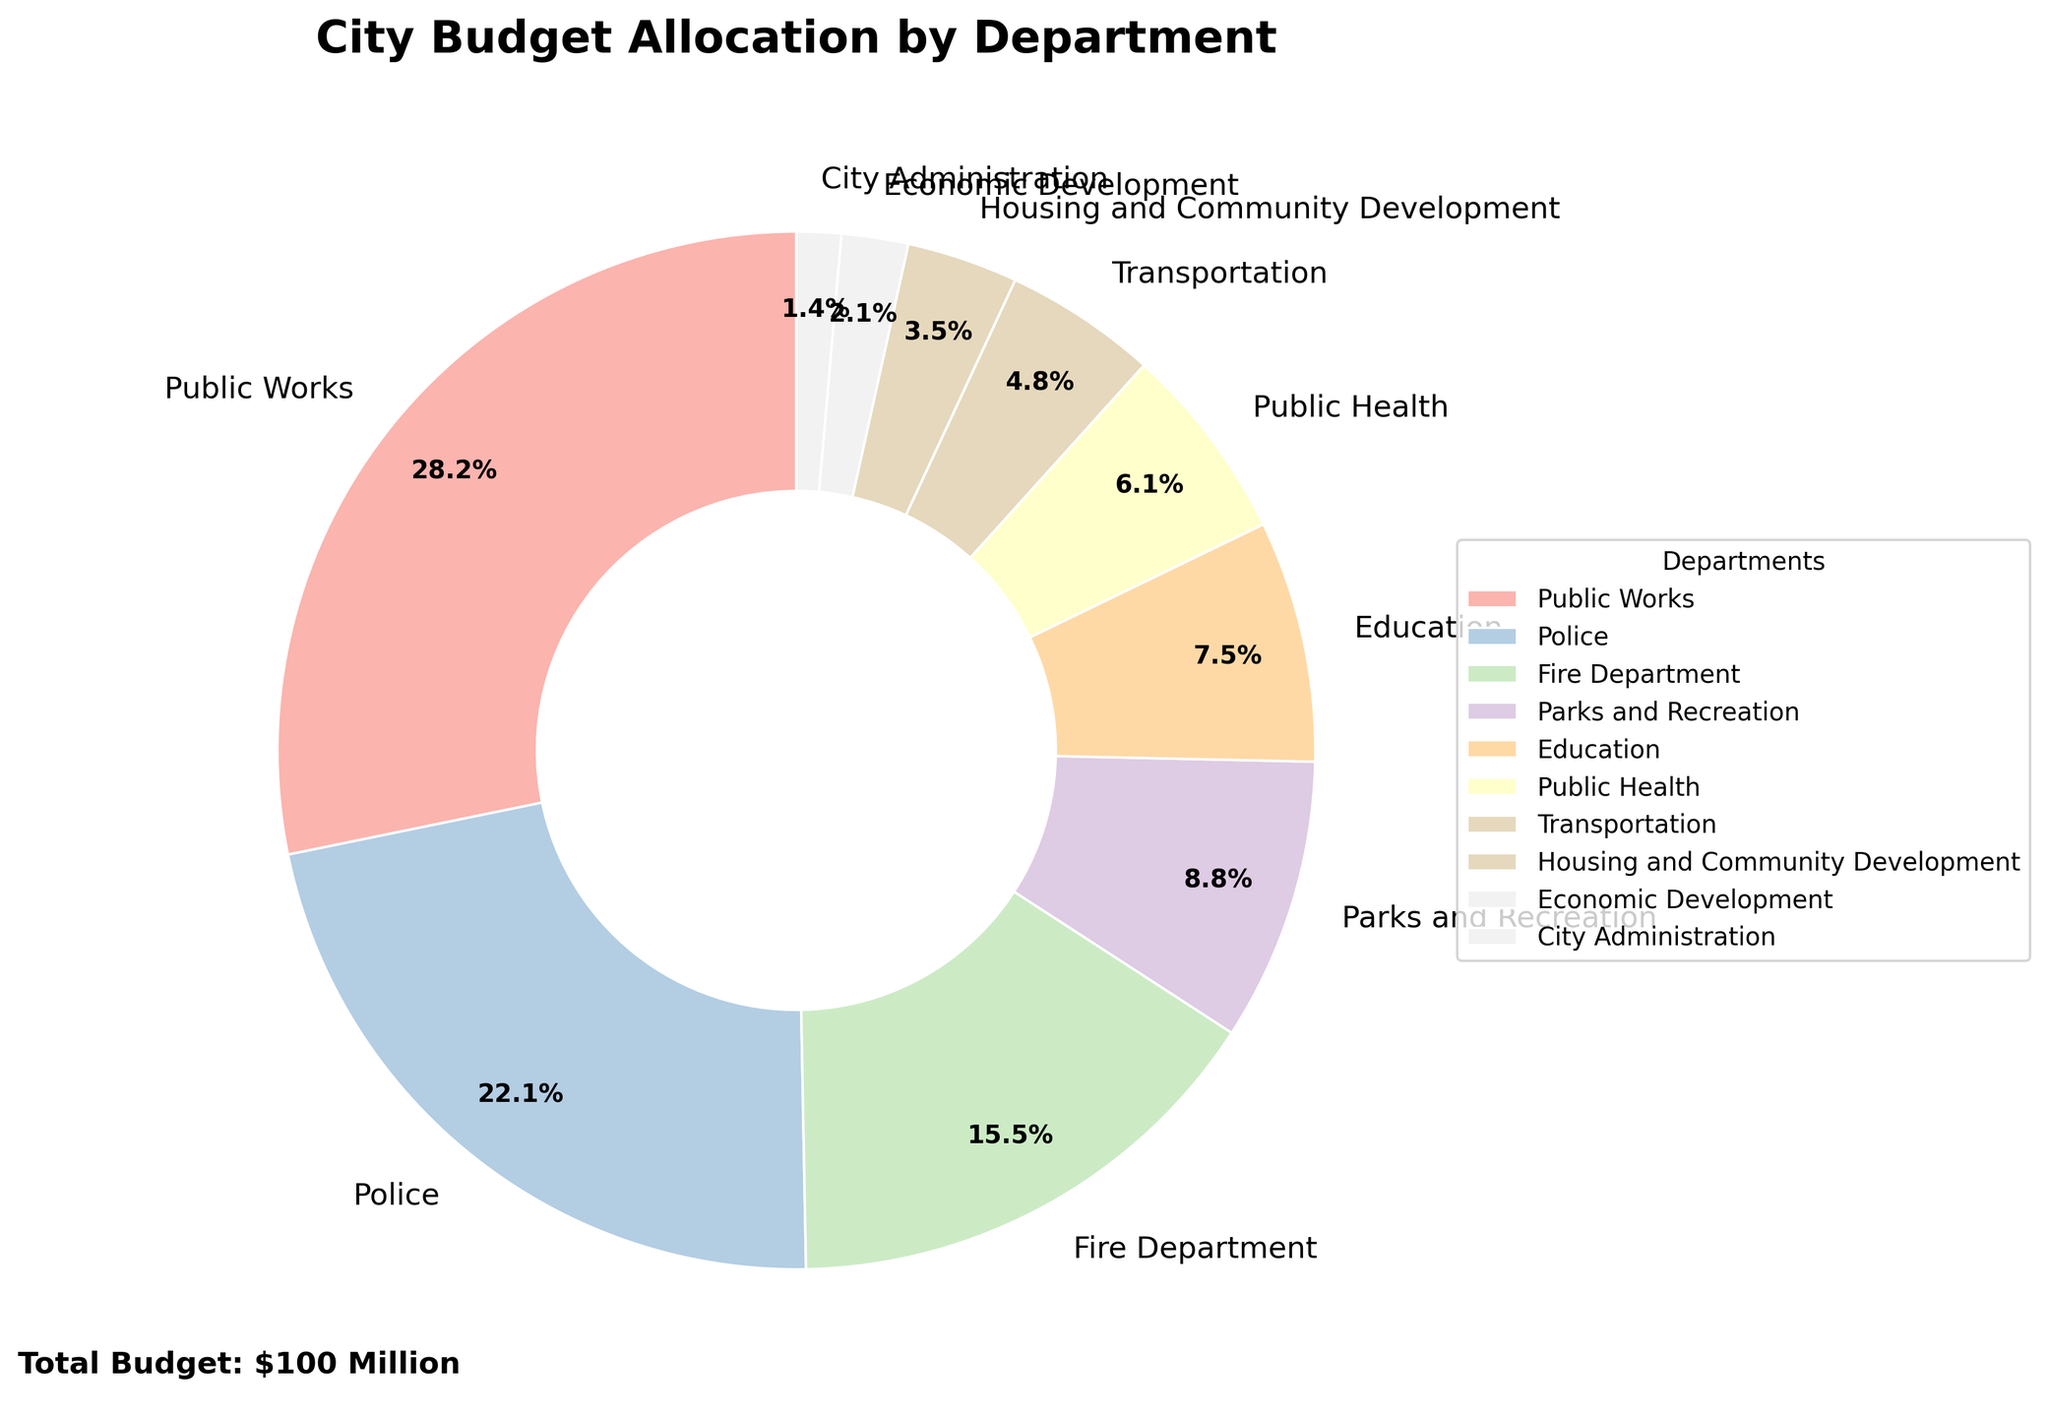What percentage of the city budget is allocated to the Police Department? The pie chart indicates that the Police Department has a specific wedge with a percentage labeled. To identify this percentage, locate the Police Department label and read the percentage value next to it.
Answer: 22.3% How does the budget allocation for Public Works compare to that for Public Health? The pie chart shows budget allocations labeled by department. Find the wedges for Public Works and Public Health and compare their labeled percentages. Public Works is listed with 28.5%, and Public Health with 6.2%. Therefore, Public Works has a higher allocation.
Answer: Public Works has a higher allocation Which department has the smallest allocation of the city budget? Examine all the wedges in the pie chart and identify the smallest percentage label. The smallest segment in the pie chart represents City Administration with 1.4%.
Answer: City Administration What is the combined budget allocation for the Education and Transportation departments? Locate the pie chart wedges and their percentage values for the Education (7.6%) and Transportation (4.8%) departments. Add these percentages together: 7.6% + 4.8% = 12.4%.
Answer: 12.4% Is the Fire Department's budget allocation greater than the combined allocation for Parks and Recreation and Public Health? Identify the wedge percentages for the Fire Department (15.7%), Parks and Recreation (8.9%), and Public Health (6.2%). Sum the allocations for Parks and Recreation and Public Health: 8.9% + 6.2% = 15.1%. Compare 15.7% to 15.1%. Yes, the Fire Department’s allocation is greater.
Answer: Yes How does the combined budget allocation for Economic Development and Housing and Community Development compare to the Education Department? Find the percentages for Economic Development (2.1%), Housing and Community Development (3.5%), and Education (7.6%). Add the percentages for Economic Development and Housing and Community Development: 2.1% + 3.5% = 5.6%. Compare 5.6% with 7.6%. The Education Department has a higher allocation.
Answer: Education Department has a higher allocation 